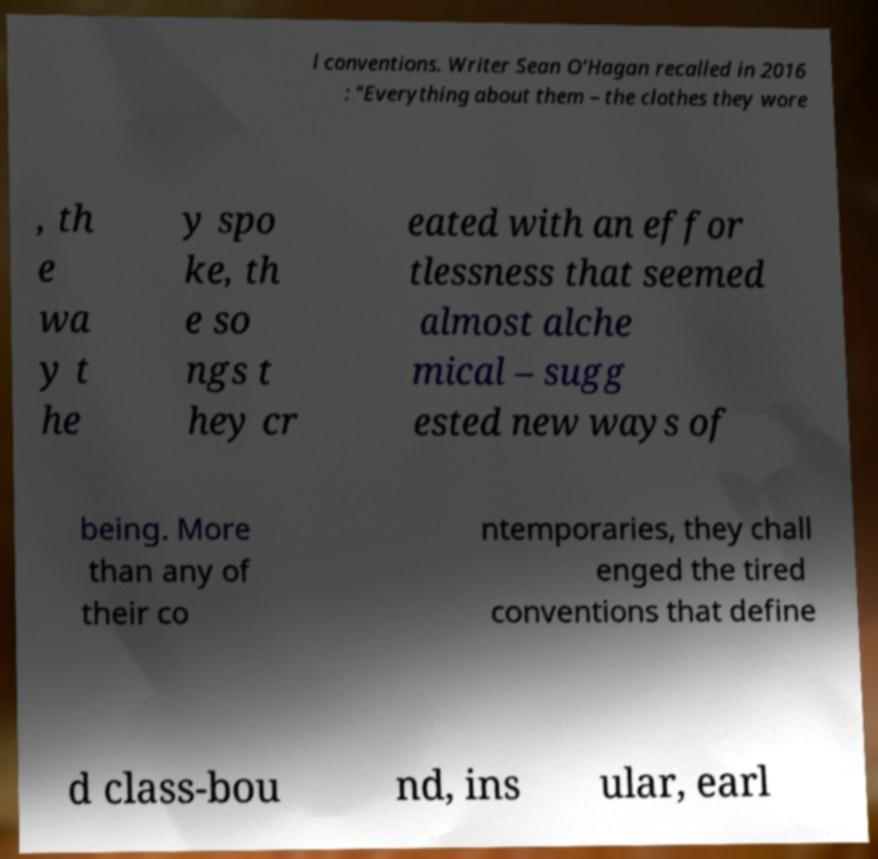For documentation purposes, I need the text within this image transcribed. Could you provide that? l conventions. Writer Sean O'Hagan recalled in 2016 : "Everything about them – the clothes they wore , th e wa y t he y spo ke, th e so ngs t hey cr eated with an effor tlessness that seemed almost alche mical – sugg ested new ways of being. More than any of their co ntemporaries, they chall enged the tired conventions that define d class-bou nd, ins ular, earl 